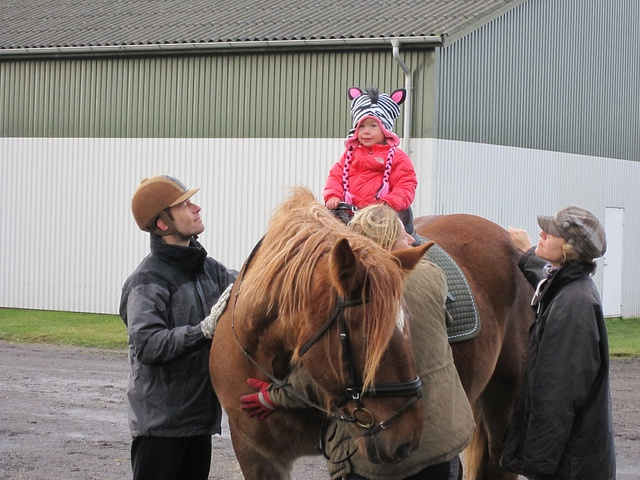Describe the objects in this image and their specific colors. I can see horse in gray, black, maroon, and brown tones, people in gray, black, brown, and darkgray tones, people in gray, black, darkgray, and lightgray tones, and people in gray, salmon, red, and lightpink tones in this image. 